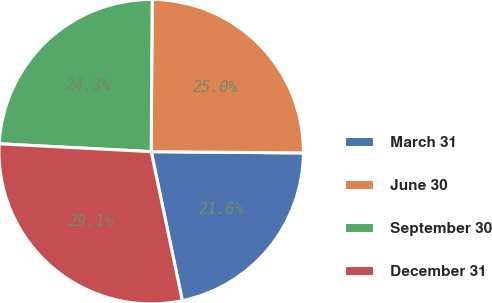Convert chart to OTSL. <chart><loc_0><loc_0><loc_500><loc_500><pie_chart><fcel>March 31<fcel>June 30<fcel>September 30<fcel>December 31<nl><fcel>21.59%<fcel>25.03%<fcel>24.28%<fcel>29.1%<nl></chart> 